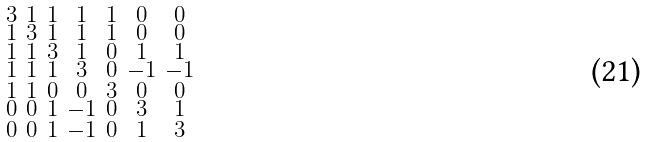<formula> <loc_0><loc_0><loc_500><loc_500>\begin{smallmatrix} 3 & 1 & 1 & 1 & 1 & 0 & 0 \\ 1 & 3 & 1 & 1 & 1 & 0 & 0 \\ 1 & 1 & 3 & 1 & 0 & 1 & 1 \\ 1 & 1 & 1 & 3 & 0 & - 1 & - 1 \\ 1 & 1 & 0 & 0 & 3 & 0 & 0 \\ 0 & 0 & 1 & - 1 & 0 & 3 & 1 \\ 0 & 0 & 1 & - 1 & 0 & 1 & 3 \end{smallmatrix}</formula> 